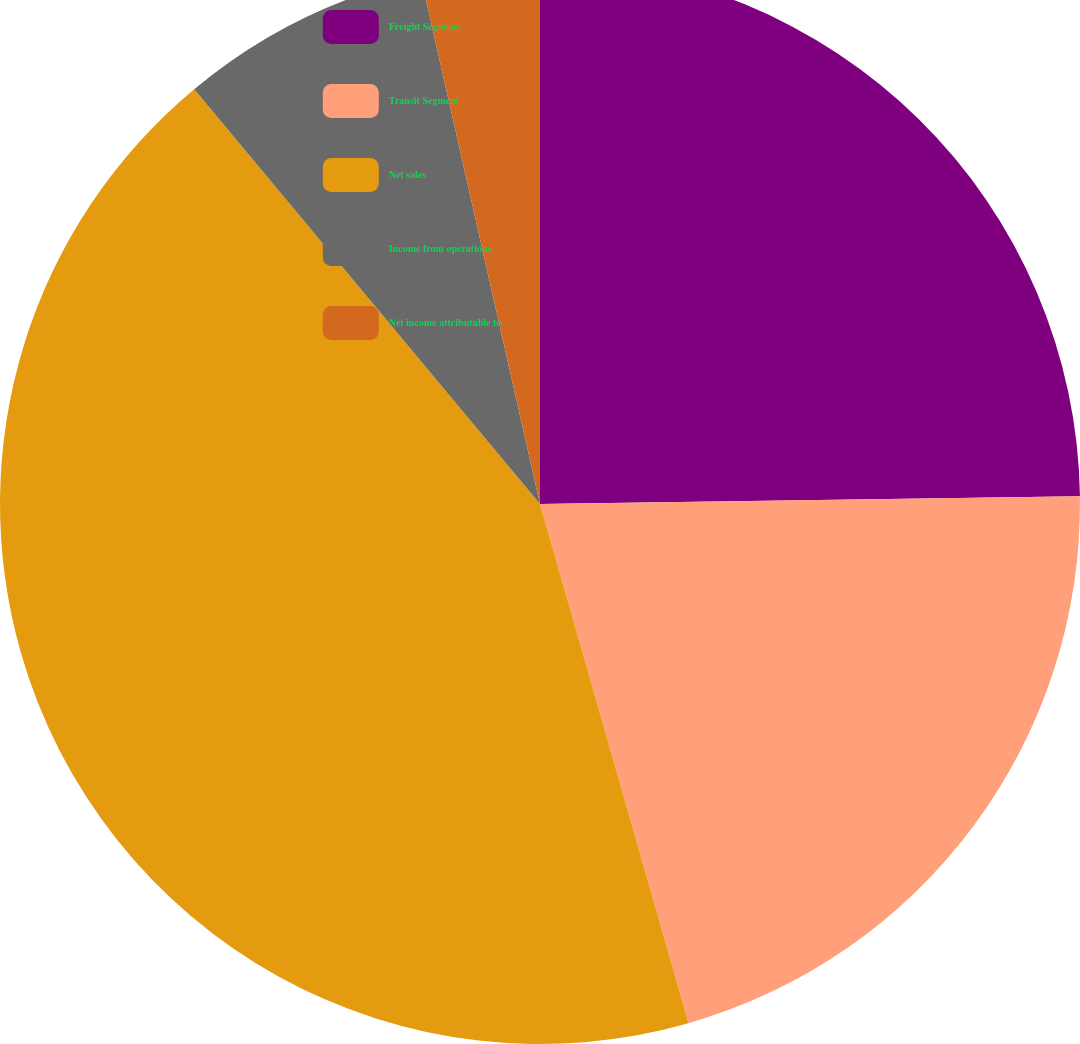Convert chart to OTSL. <chart><loc_0><loc_0><loc_500><loc_500><pie_chart><fcel>Freight Segment<fcel>Transit Segment<fcel>Net sales<fcel>Income from operations<fcel>Net income attributable to<nl><fcel>24.77%<fcel>20.79%<fcel>43.37%<fcel>7.52%<fcel>3.54%<nl></chart> 